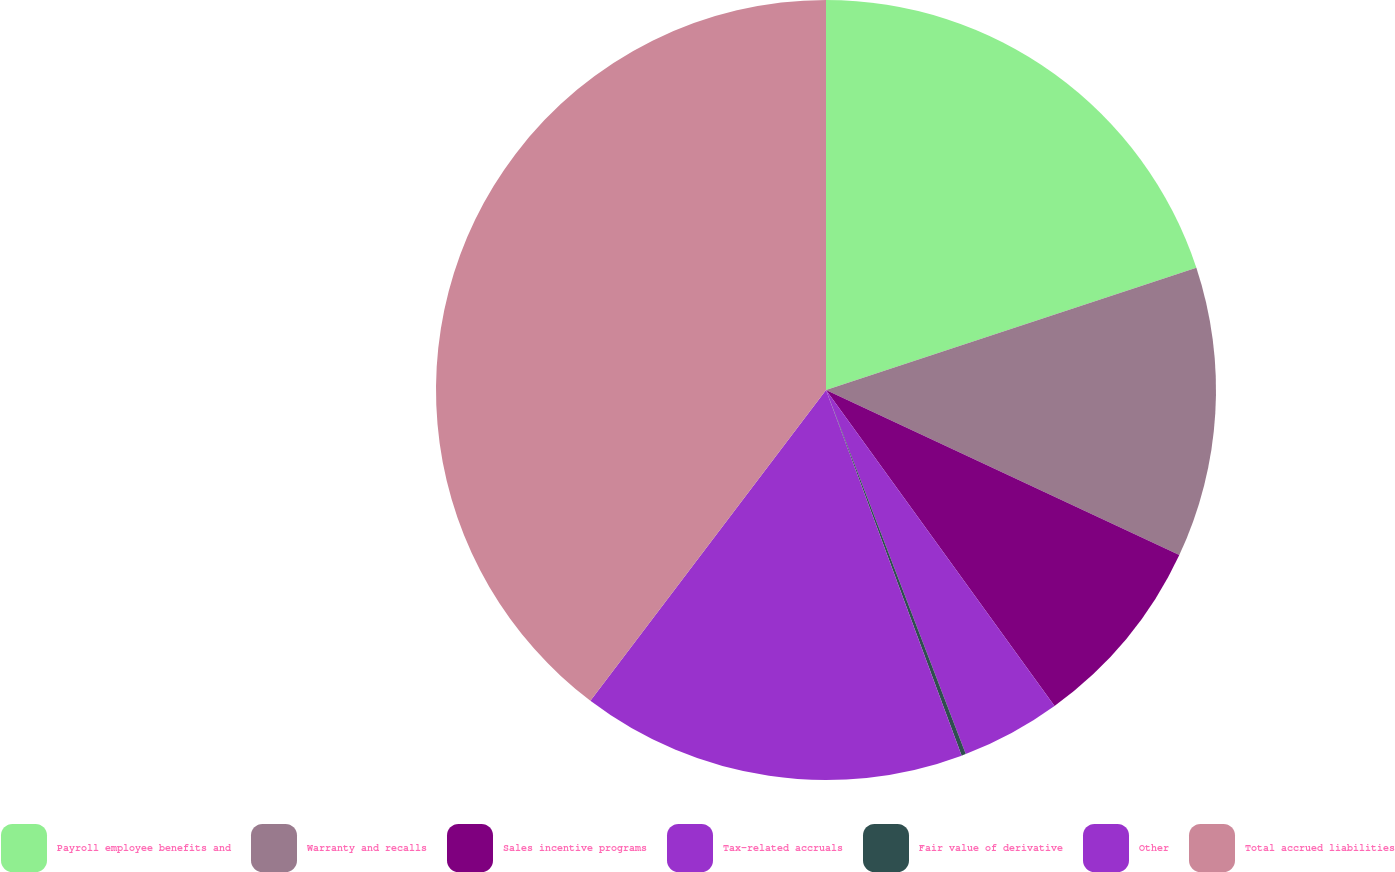<chart> <loc_0><loc_0><loc_500><loc_500><pie_chart><fcel>Payroll employee benefits and<fcel>Warranty and recalls<fcel>Sales incentive programs<fcel>Tax-related accruals<fcel>Fair value of derivative<fcel>Other<fcel>Total accrued liabilities<nl><fcel>19.93%<fcel>12.03%<fcel>8.08%<fcel>4.13%<fcel>0.18%<fcel>15.98%<fcel>39.68%<nl></chart> 